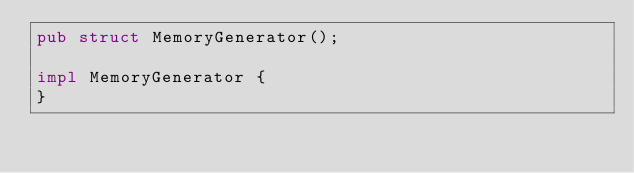Convert code to text. <code><loc_0><loc_0><loc_500><loc_500><_Rust_>pub struct MemoryGenerator();

impl MemoryGenerator {
}
</code> 